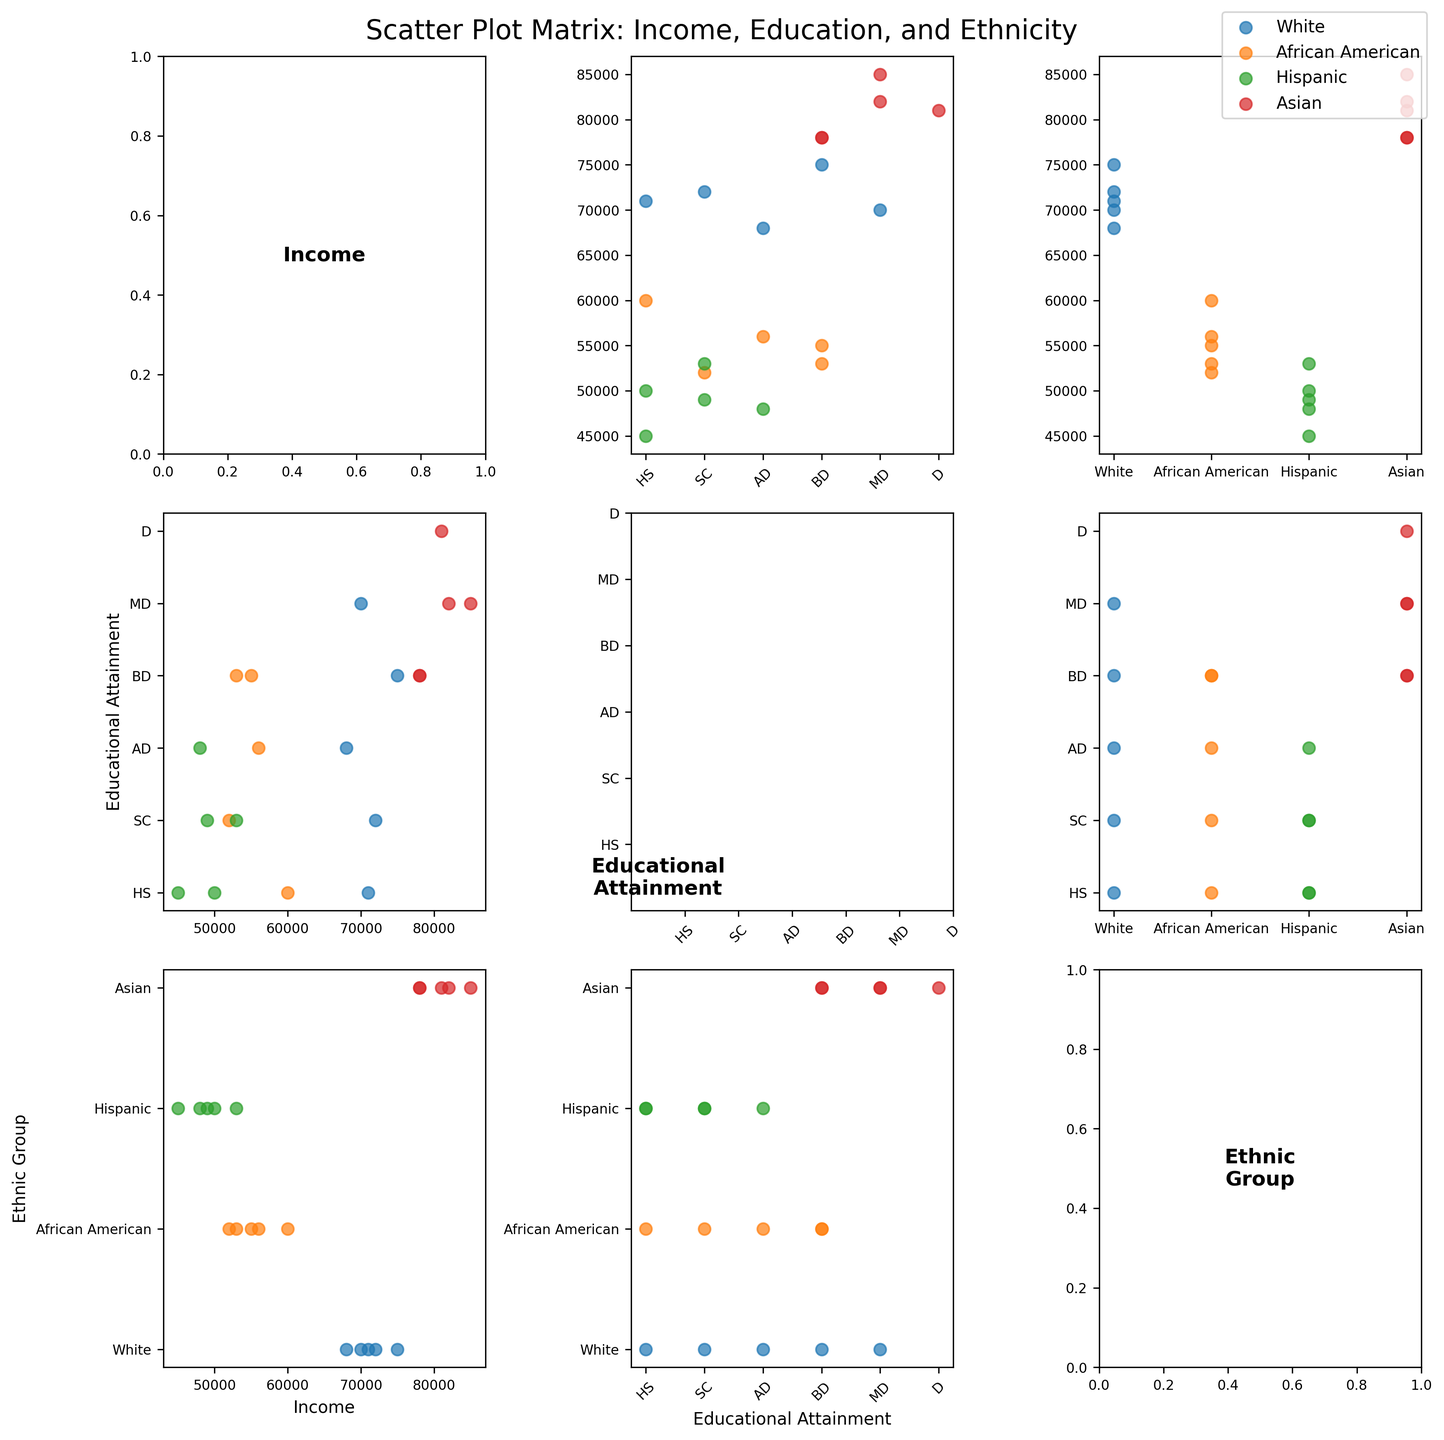What's the title of the figure? The title is located at the top of the figure, which provides an overview of what the figure represents. In this case, look for the text at the top center of the figure.
Answer: Scatter Plot Matrix: Income, Education, and Ethnicity Which ethnic group is represented by the color red? The figure legend or color key will indicate which color represents each ethnic group. Find the color red in the legend to see which ethnic group it corresponds to.
Answer: Asian How does income relate to educational attainment for African Americans in Los Angeles? Find the scatter plot where "Income" is on one axis and "Educational_Attainment" on the other, and identify the data points for African Americans in Los Angeles (use color and location labels). Observe the trend.
Answer: As educational attainment increases, income appears to also increase for African Americans in Los Angeles Which ethnic group has the highest educational attainment in New York? Identify the data points for New York and look for the highest values in the "Educational Attainment" variable, then see which ethnic group these points belong to by their color.
Answer: Asian Which urban area shows the highest overall income for the Hispanic ethnic group? Locate the data points for the Hispanic group by color, then identify which urban area has the highest income value among these points.
Answer: Chicago Compare the educational attainment between Whites in Chicago and Asians in Houston. On the "Educational Attainment" axis, locate the data points for Whites in Chicago and Asians in Houston, then compare their positions to determine who has higher educational attainment.
Answer: Asians in Houston What is the general trend between income and educational attainment across all ethnic groups? Observe the overall pattern in the scatter plots that plot Income against Educational Attainment. Look for a trend line or clustering of data points.
Answer: Generally, higher educational attainment correlates with higher income Which ethnic group has the most variable income distribution in urban areas? Inspect the spread of data points along the income axis for each ethnic group across different plots. The group with the widest spread has the most variable income distribution.
Answer: White In which city do we observe the widest range of educational attainment across different ethnic groups? Examine the scatter plots for each city, looking at the spread of data points along the educational attainment axis for various ethnic groups. The city with the widest spread has the greatest range.
Answer: Chicago Is there a specific educational attainment level where Hispanic individuals seem to have particularly clustered incomes? Find the scatter plots containing Hispanic data points and look for concentrations around specific educational attainment values.
Answer: Some College 